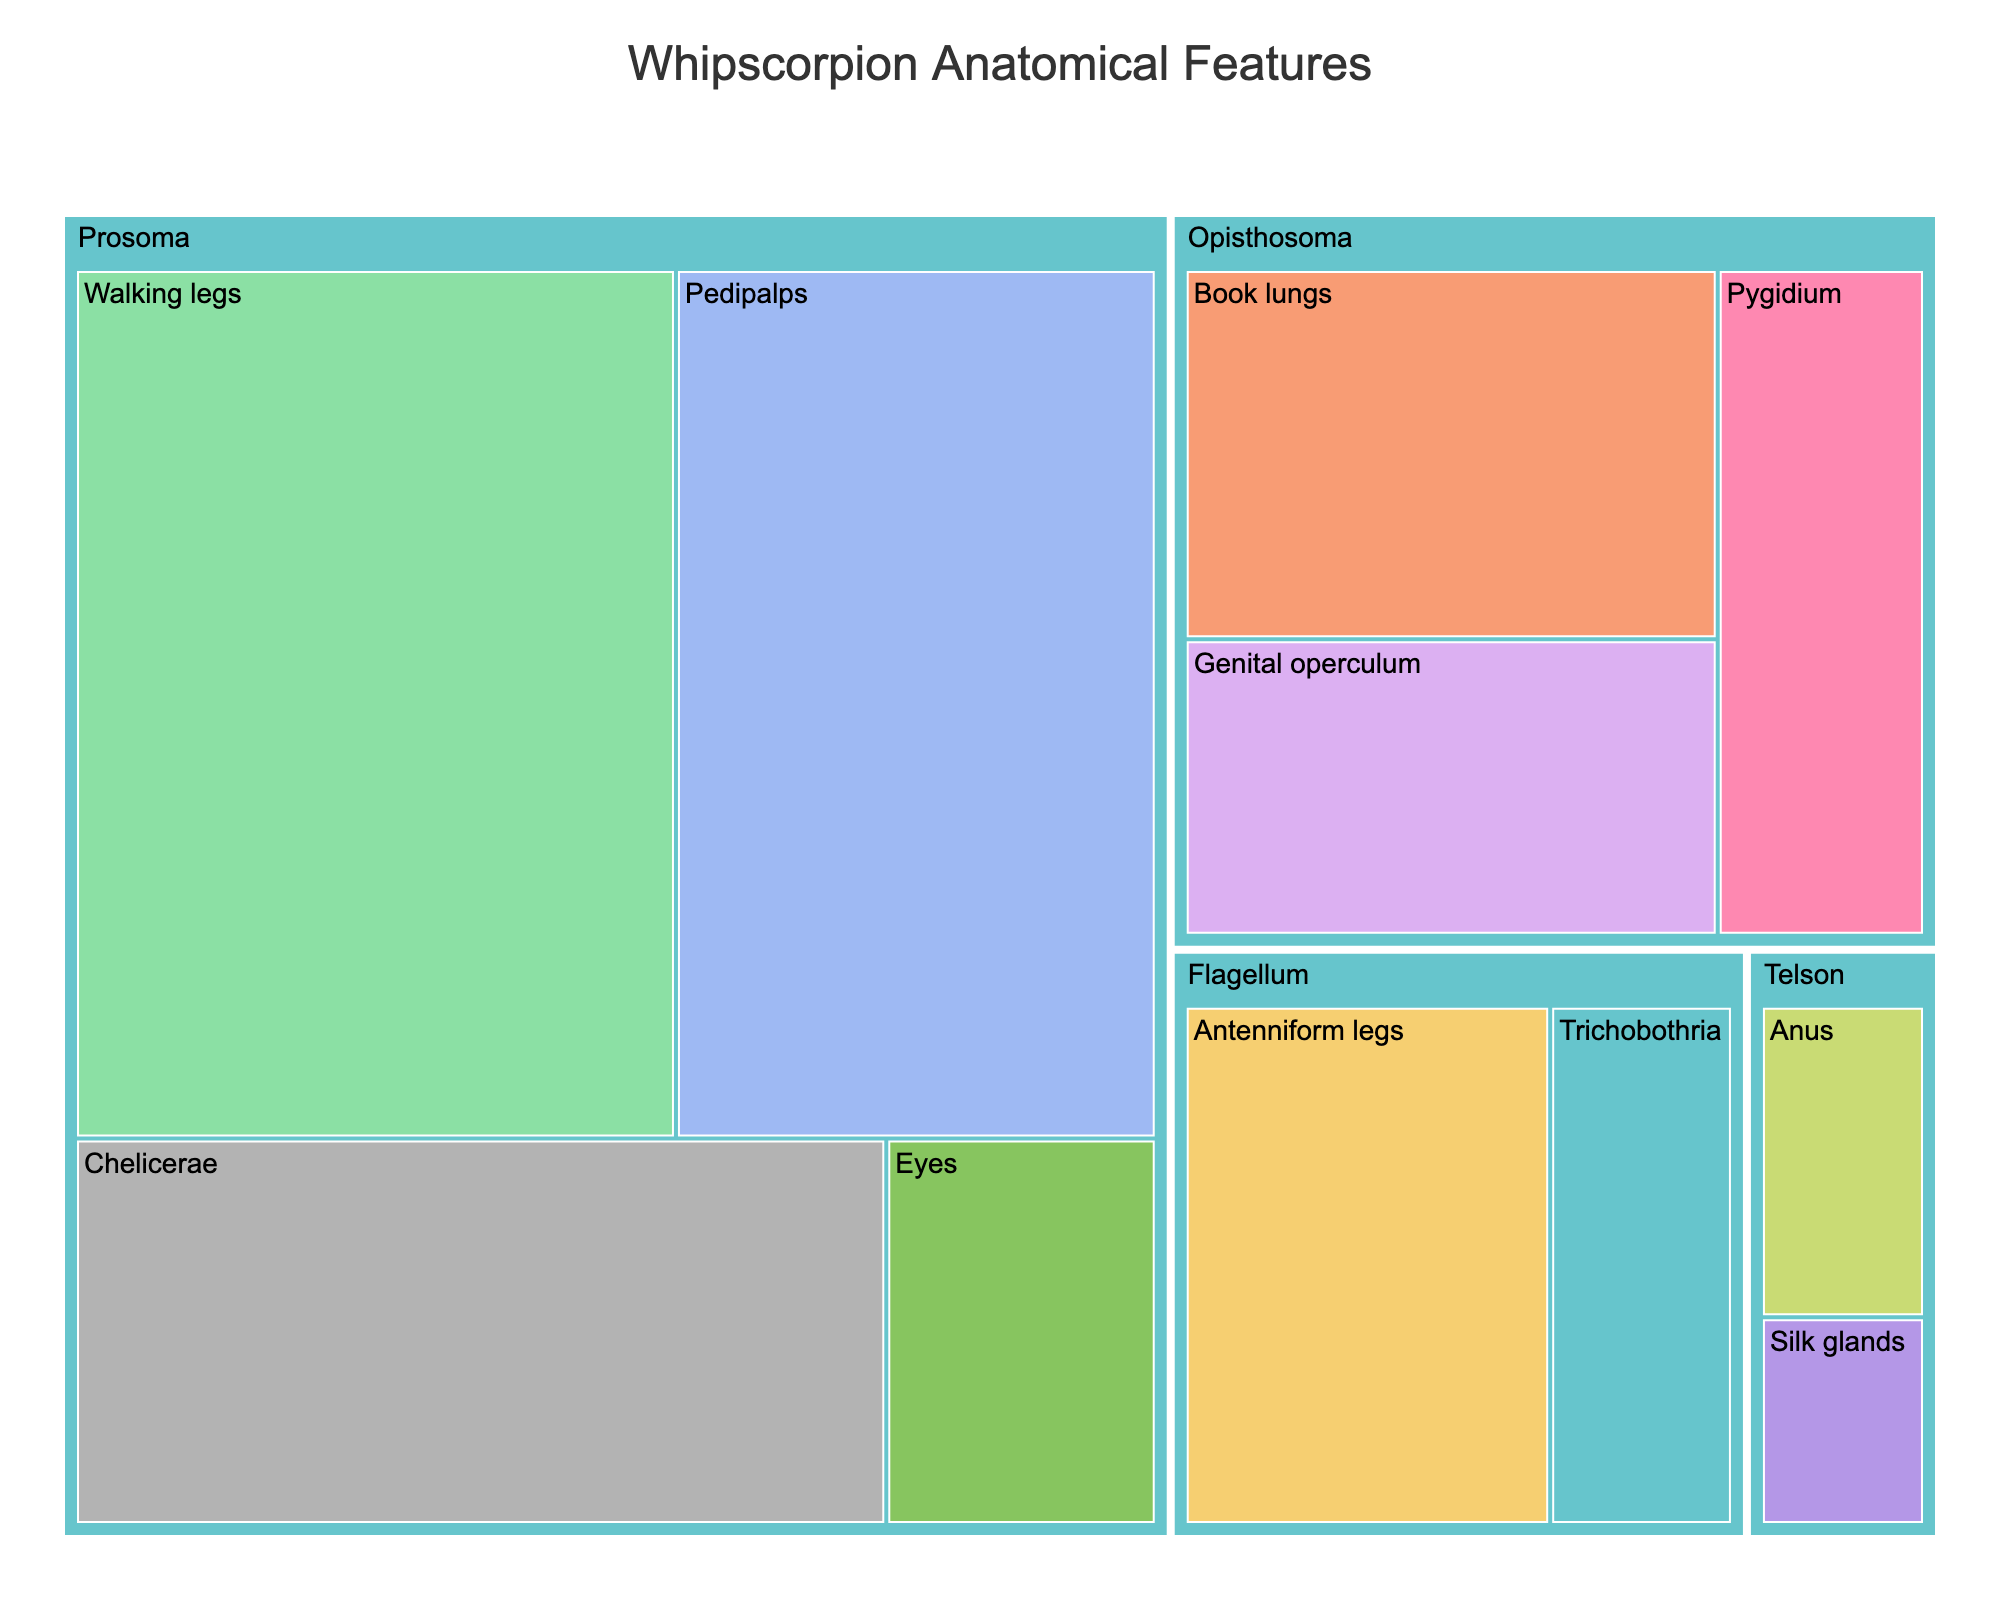What's the title of the treemap? The title is usually prominently displayed at the top of the figure.
Answer: Whipscorpion Anatomical Features Which body segment has the most significant feature size overall? By visually comparing the sizes of the aggregated section for each body segment, it's evident which one takes up the most space.
Answer: Prosoma How many distinct functions are represented in the treemap? Count the different color-coded functions in the legend or within the treemap itself.
Answer: 7 Which feature contributes the most to respiration function? Look for features under a color segment labeled "Respiration" and identify the one with the largest area.
Answer: Book lungs What is the total size of all features in the telson? Sum up the sizes of the features under the telson segment: Anus (3) + Silk glands (2).
Answer: 5 Which segment has the least variation in feature function? Observe which segment's features predominantly indicate the same function.
Answer: Telson Compare the sizes of Pedipalps and Antenniform legs. Which one is larger? Combine the visual areas or their stated sizes: Pedipalps (20) vs. Antenniform legs (10).
Answer: Pedipalps What's the combined size of sensory-related features across all body segments? Sum the sizes of all sensory-related features: Pedipalps (20) + Pygidium (7) + Antenniform legs (10) + Trichobothria (5).
Answer: 42 Which feature occupies the smallest area in the treemap? Identify the smallest block visually in the treemap.
Answer: Silk glands Compare the total size of features in the Prosoma to those in the Opisthosoma. Which one is larger? Sum up the sizes and compare: Prosoma (15 + 20 + 25 + 5 = 65) vs. Opisthosoma (10 + 8 + 7 = 25).
Answer: Prosoma 